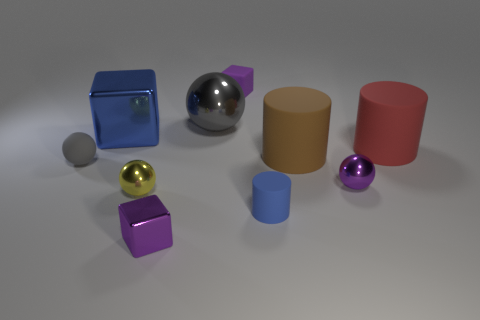There is another ball that is the same color as the tiny rubber sphere; what is its size?
Provide a succinct answer. Large. What is the size of the blue object that is the same shape as the small purple rubber thing?
Your answer should be very brief. Large. Does the large cube have the same color as the matte thing in front of the yellow metal sphere?
Offer a terse response. Yes. Is the tiny cylinder the same color as the large block?
Provide a short and direct response. Yes. Are there fewer yellow metallic objects than big blue rubber balls?
Make the answer very short. No. How many other things are there of the same color as the matte sphere?
Offer a very short reply. 1. How many small gray rubber balls are there?
Keep it short and to the point. 1. Are there fewer small cubes behind the small gray sphere than blocks?
Keep it short and to the point. Yes. Does the gray object behind the gray matte ball have the same material as the small blue thing?
Keep it short and to the point. No. There is a purple metallic object that is right of the small rubber object that is in front of the gray thing on the left side of the big gray thing; what shape is it?
Your answer should be compact. Sphere. 